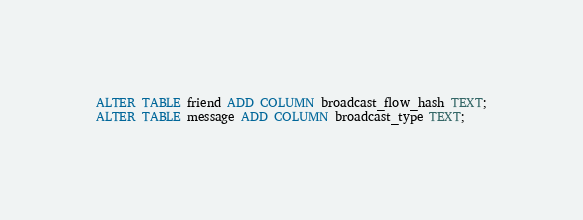<code> <loc_0><loc_0><loc_500><loc_500><_SQL_>ALTER TABLE friend ADD COLUMN broadcast_flow_hash TEXT;
ALTER TABLE message ADD COLUMN broadcast_type TEXT;</code> 